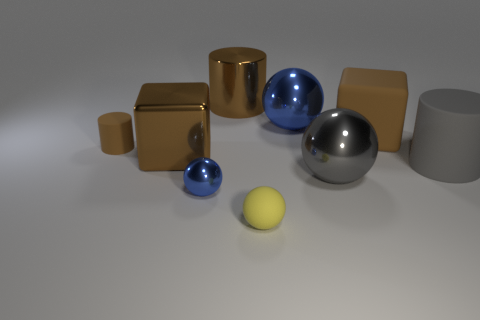Is the size of the gray cylinder the same as the metallic block?
Your answer should be very brief. Yes. How many other objects are there of the same shape as the small shiny thing?
Your response must be concise. 3. What material is the big block on the left side of the shiny sphere that is behind the big gray metallic ball?
Keep it short and to the point. Metal. Are there any gray metallic things on the left side of the big blue thing?
Your response must be concise. No. Does the brown shiny cube have the same size as the cylinder that is on the right side of the small yellow sphere?
Your answer should be compact. Yes. The other blue shiny thing that is the same shape as the large blue metallic object is what size?
Offer a terse response. Small. There is a matte object in front of the big gray metallic object; is it the same size as the blue object in front of the big gray rubber cylinder?
Provide a short and direct response. Yes. How many large objects are either blue metal objects or metallic blocks?
Provide a succinct answer. 2. What number of rubber things are on the right side of the tiny yellow rubber thing and behind the big metal cube?
Provide a short and direct response. 1. Does the big blue sphere have the same material as the brown cylinder to the left of the large brown cylinder?
Provide a short and direct response. No. 